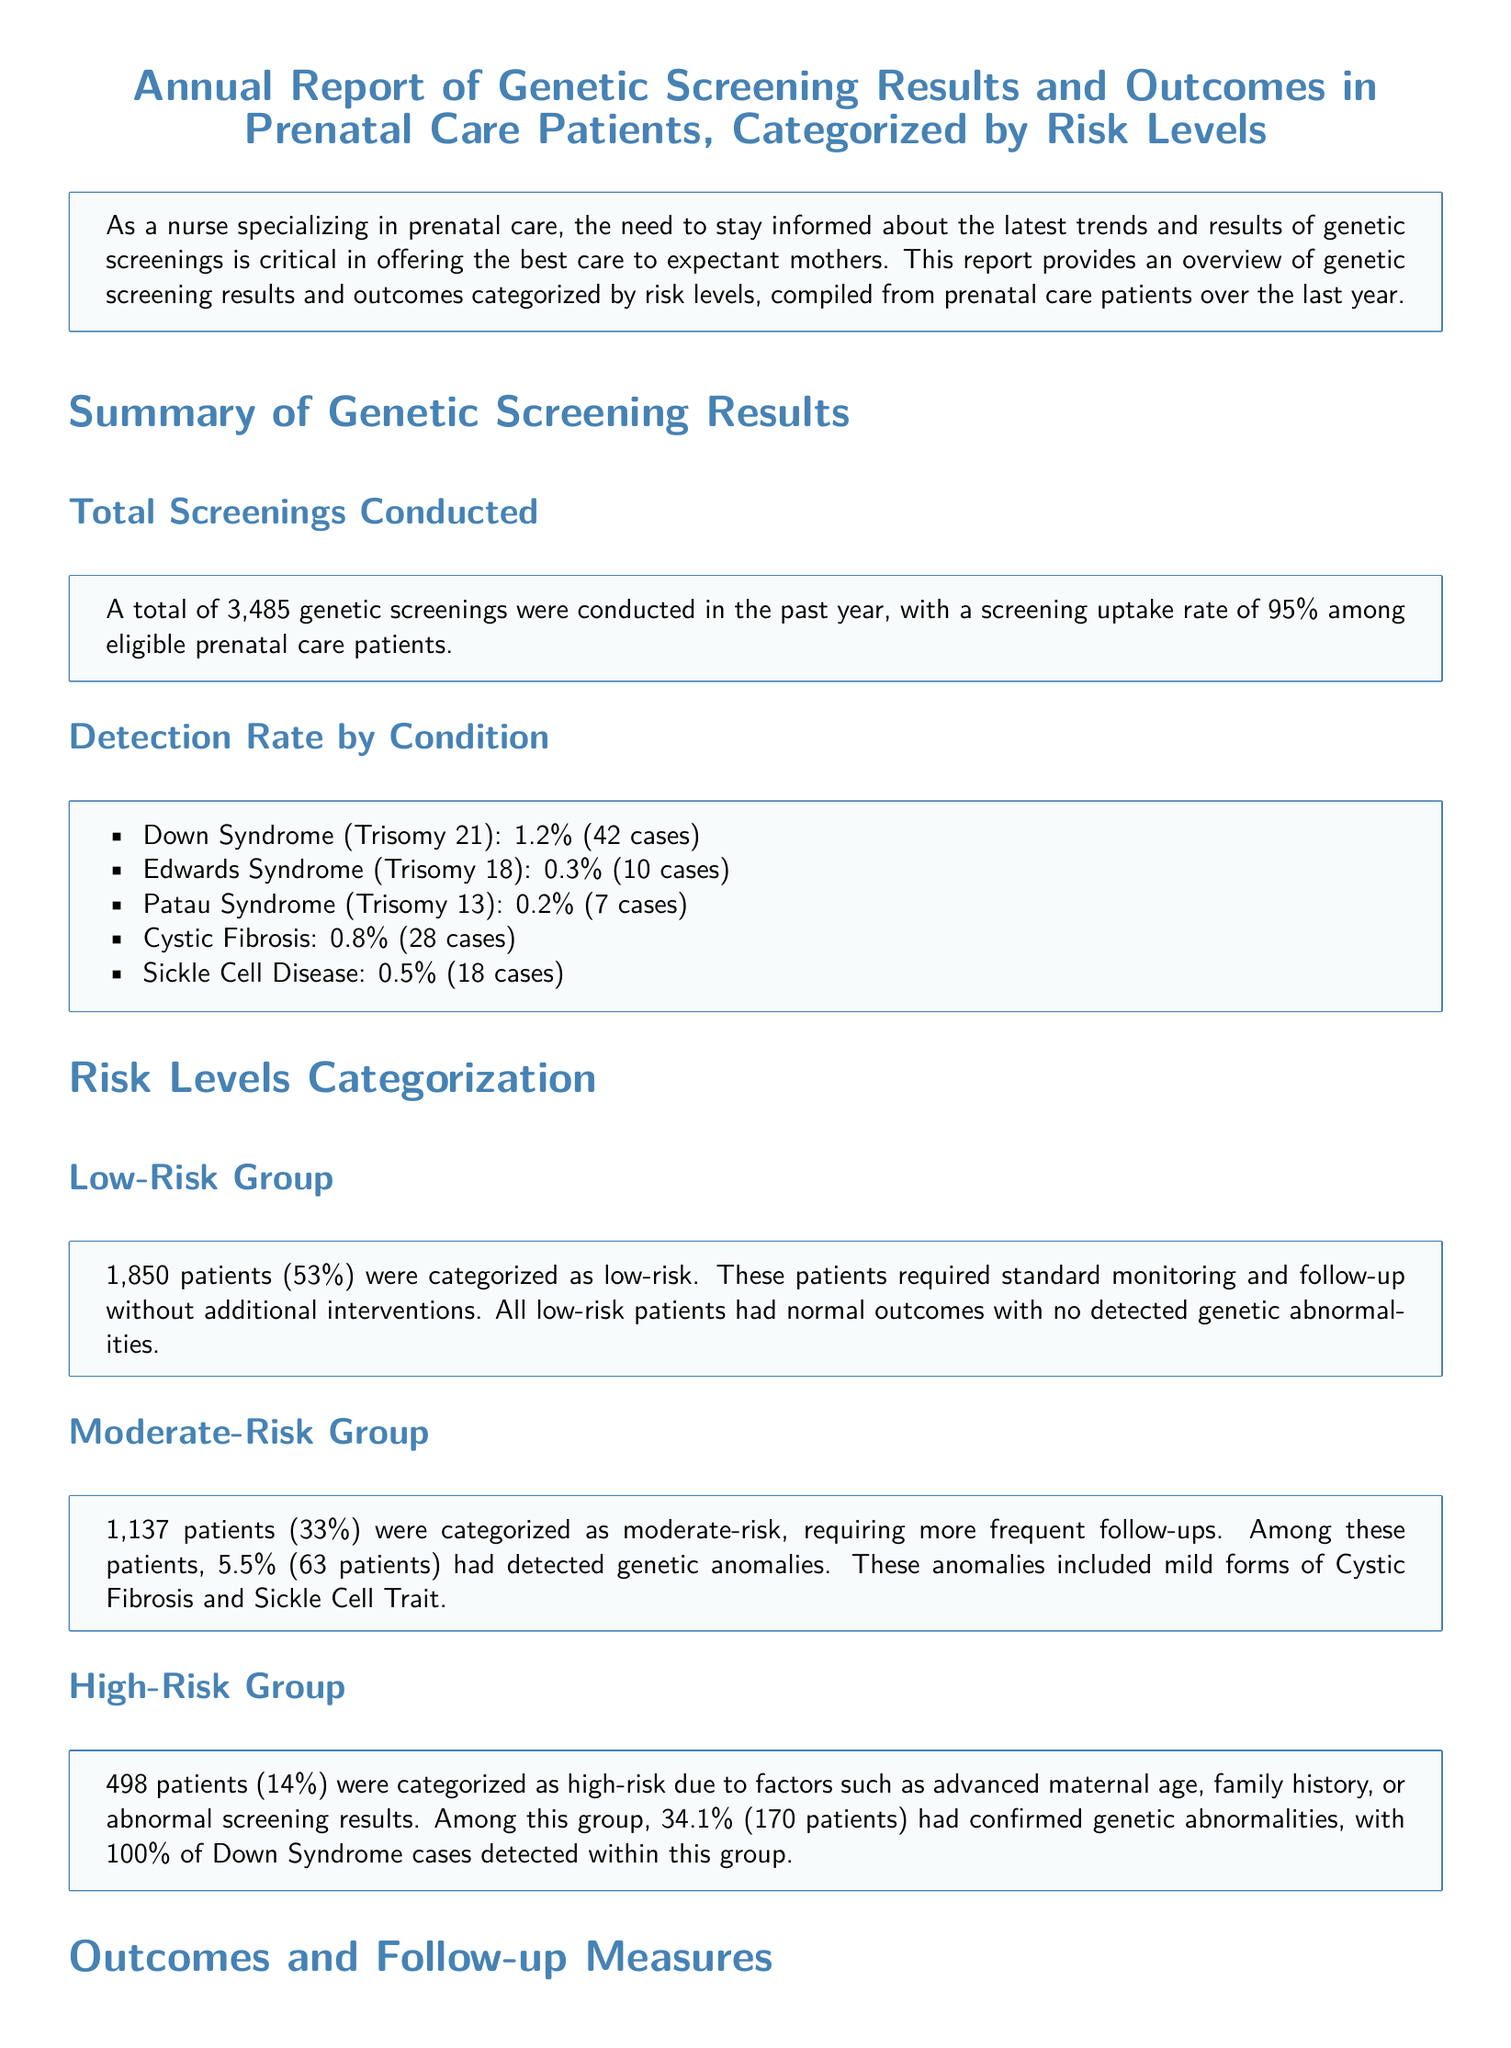What was the total number of genetic screenings conducted? The total number of genetic screenings conducted is explicitly stated in the document.
Answer: 3,485 What percentage of eligible prenatal care patients participated in screenings? The screening uptake rate is provided clearly in the document.
Answer: 95% How many patients were categorized as high-risk? The number of patients in the high-risk category is specified directly in the text.
Answer: 498 What percentage of the high-risk group had confirmed genetic abnormalities? The document provides the percentage for confirmed genetic abnormalities in the high-risk group.
Answer: 34.1% Which genetic disorder had a detection rate of 1.2%? The specific genetic disorder and its detection rate is mentioned in the results section.
Answer: Down Syndrome What follow-up diagnostic tests were offered to patients with positive screening results? The specific diagnostic tests available for patients with positive tests are listed in the outcomes section of the document.
Answer: Amniocentesis or chorionic villus sampling How many patients in the moderate-risk group had detected genetic anomalies? The number of patients with genetic anomalies in this risk category is directly stated.
Answer: 63 What was the patient satisfaction rate reported in the document? The satisfaction rate as expressed in post-screening surveys is highlighted in the feedback section.
Answer: 92% What was one of the main focuses moving forward as stated in the report? A focus area for future improvements is detailed in the concluding remarks.
Answer: Enhancing patient education 